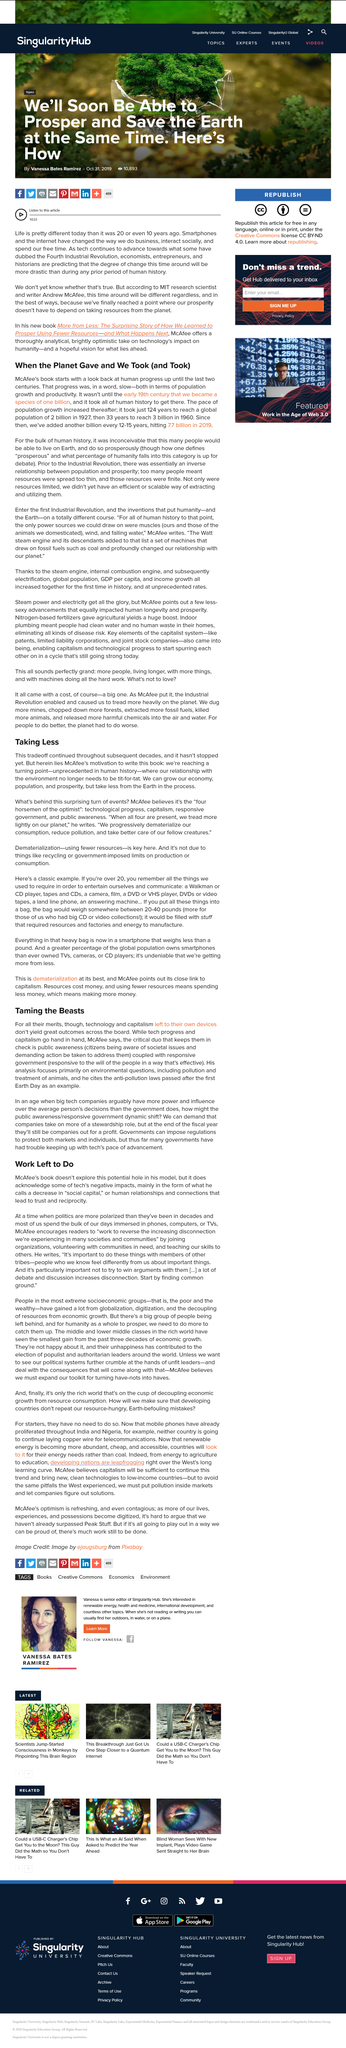Outline some significant characteristics in this image. McAfee wrote the book, which he did... In 1960, there were 3 billion humans on earth. The turning point is unprecedented in human history, as it is. Yes, it is a part of the surprising turn of events that taking less from the Earth is occurring. In 1927, there were approximately 2 billion humans living on Earth. 